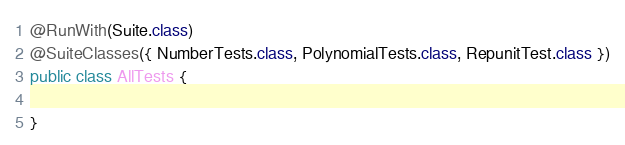Convert code to text. <code><loc_0><loc_0><loc_500><loc_500><_Java_>
@RunWith(Suite.class)
@SuiteClasses({ NumberTests.class, PolynomialTests.class, RepunitTest.class })
public class AllTests {

}
</code> 